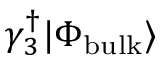Convert formula to latex. <formula><loc_0><loc_0><loc_500><loc_500>\gamma _ { 3 } ^ { \dagger } | \Phi _ { b u l k } \rangle</formula> 